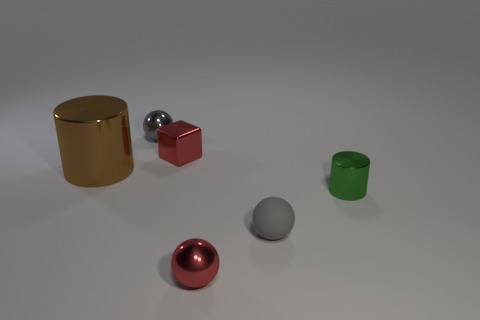There is a red object that is the same shape as the small gray shiny object; what material is it?
Give a very brief answer. Metal. Do the small red block and the gray object that is on the left side of the matte thing have the same material?
Make the answer very short. Yes. Is there anything else of the same color as the large cylinder?
Give a very brief answer. No. What number of objects are small gray spheres that are in front of the tiny green thing or small things on the left side of the gray matte thing?
Ensure brevity in your answer.  4. What is the shape of the object that is in front of the small red metallic cube and behind the green thing?
Provide a succinct answer. Cylinder. What number of gray metallic objects are right of the object that is behind the red block?
Make the answer very short. 0. Is there any other thing that is made of the same material as the brown cylinder?
Ensure brevity in your answer.  Yes. What number of things are either tiny metal objects right of the tiny gray matte sphere or large red matte spheres?
Your answer should be compact. 1. What size is the cylinder that is to the right of the small gray rubber thing?
Keep it short and to the point. Small. What material is the tiny cylinder?
Provide a short and direct response. Metal. 